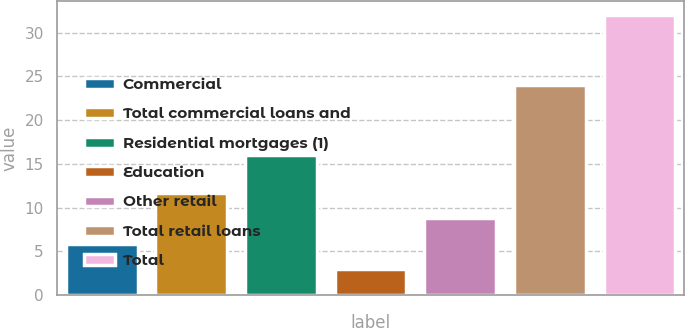Convert chart. <chart><loc_0><loc_0><loc_500><loc_500><bar_chart><fcel>Commercial<fcel>Total commercial loans and<fcel>Residential mortgages (1)<fcel>Education<fcel>Other retail<fcel>Total retail loans<fcel>Total<nl><fcel>5.9<fcel>11.7<fcel>16<fcel>3<fcel>8.8<fcel>24<fcel>32<nl></chart> 